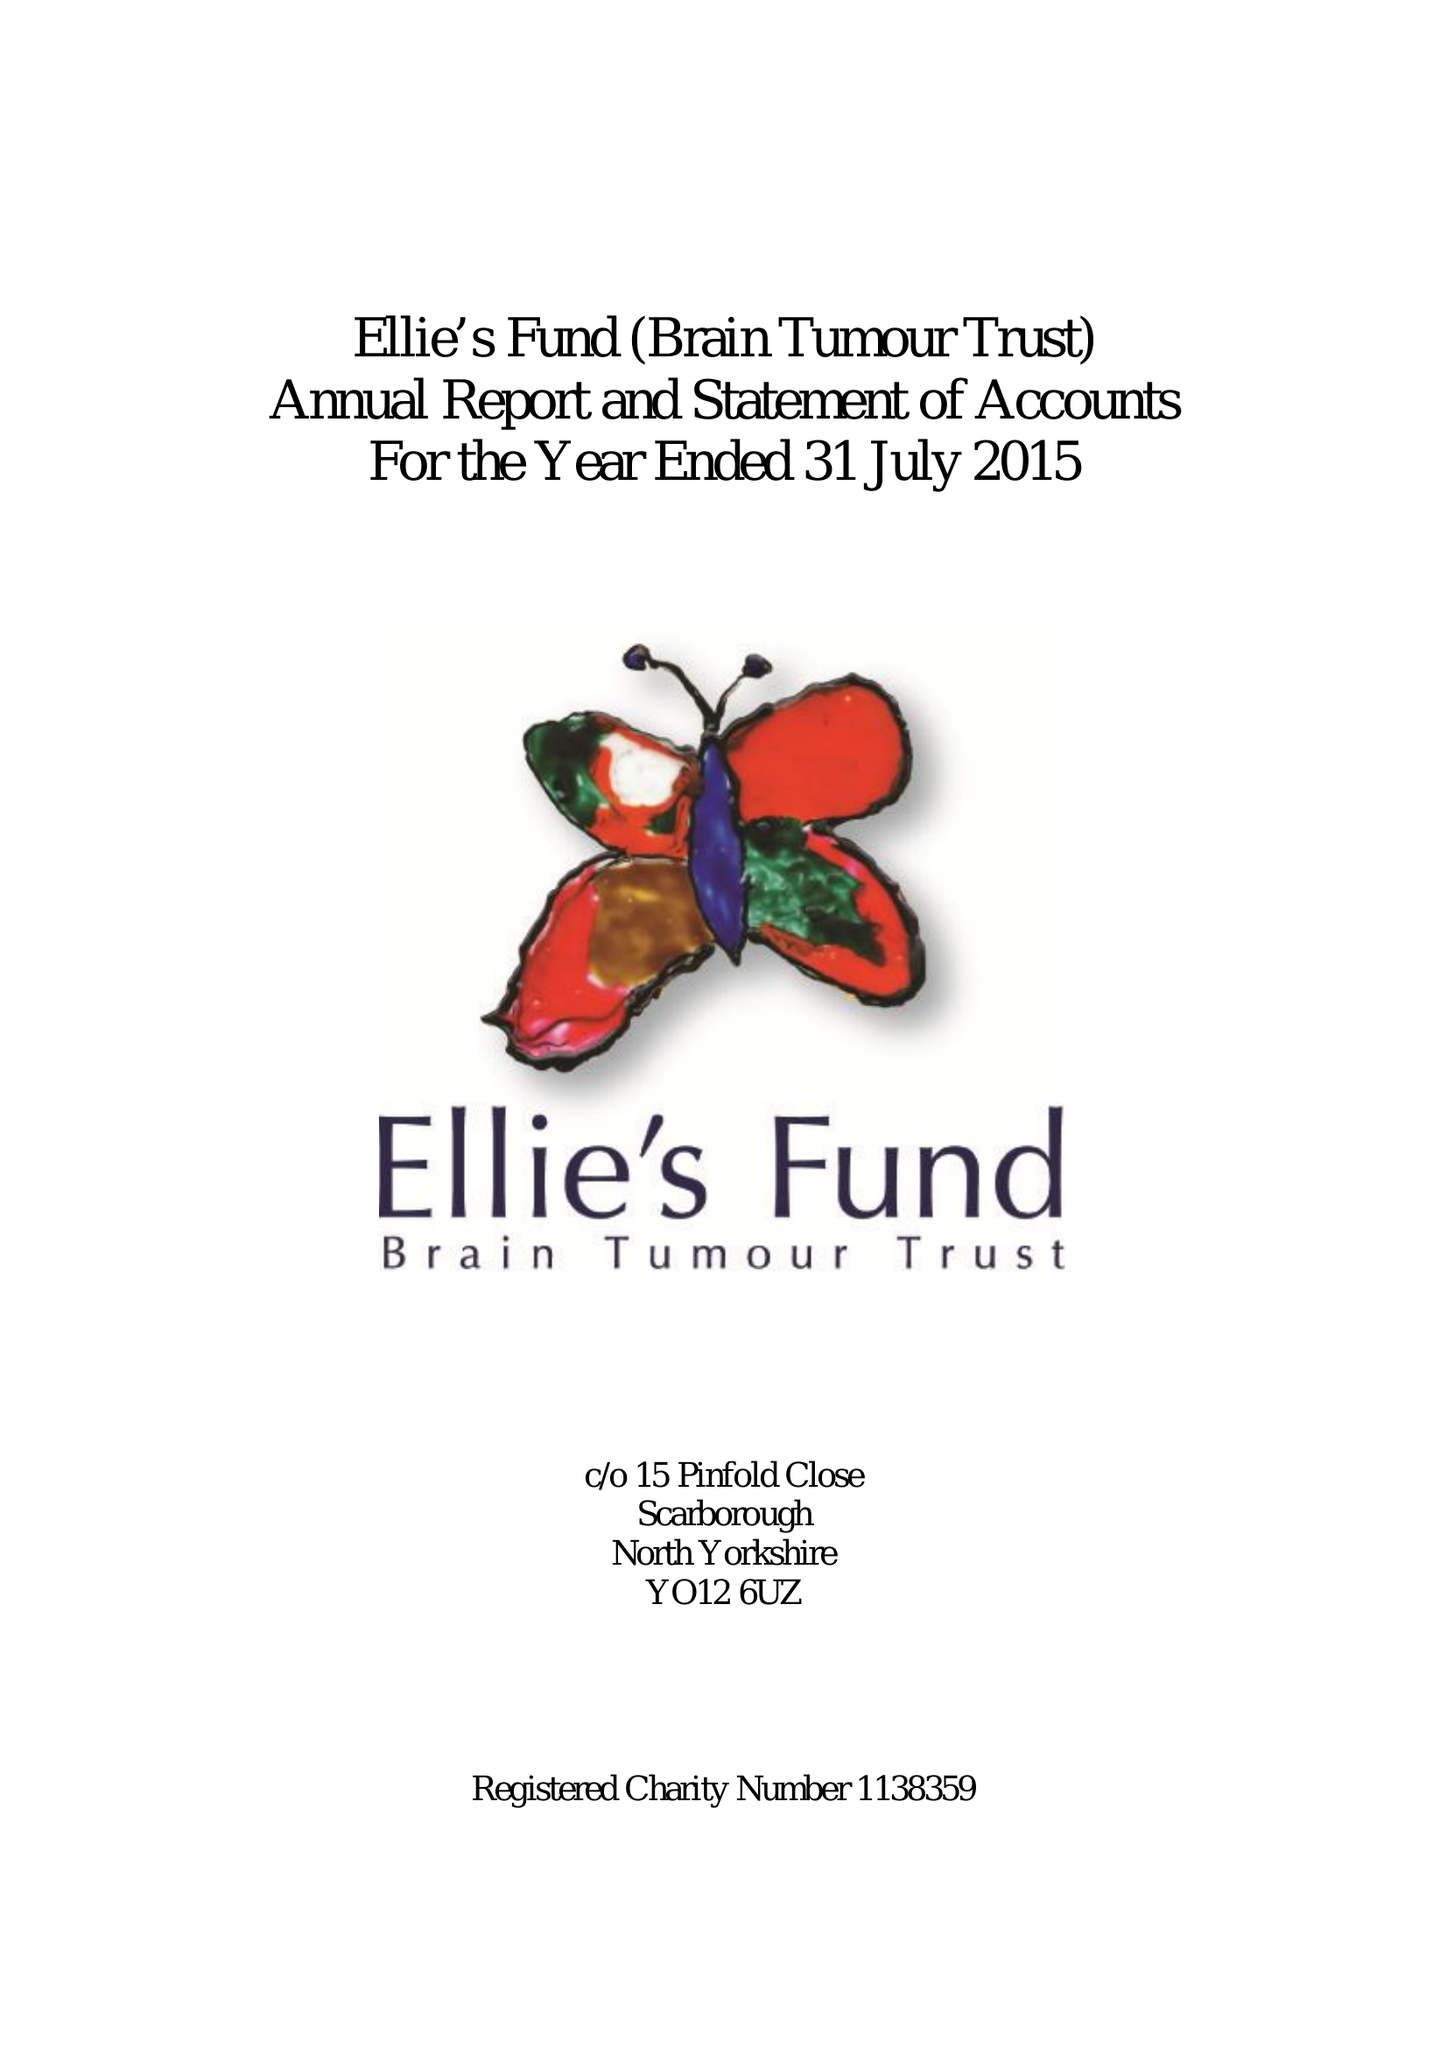What is the value for the report_date?
Answer the question using a single word or phrase. 2015-07-31 